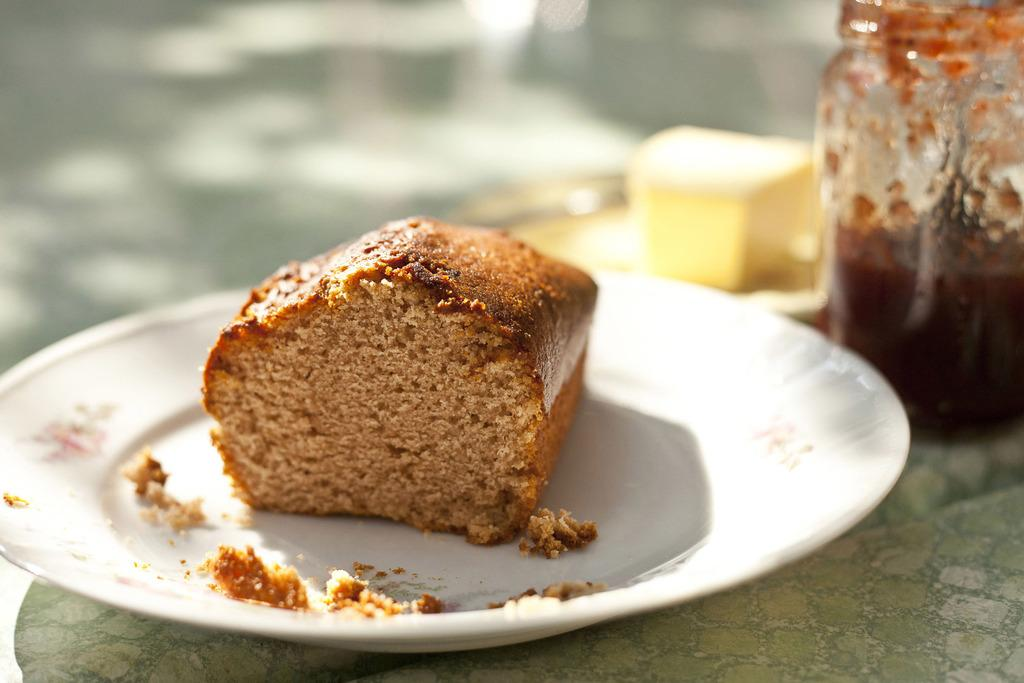What is on the plate that is visible in the image? There is a bread on a plate in the image. What is located at the bottom of the image? There is a table at the bottom of the image. What can be seen on the right side of the image? There is a jar on the right side of the image. Can you describe the background of the image? The background of the image is blurred. What type of government is depicted in the image? There is no depiction of a government in the image; it features a bread on a plate, a table, a jar, and a blurred background. How many hands are visible in the image? There are no hands visible in the image. 